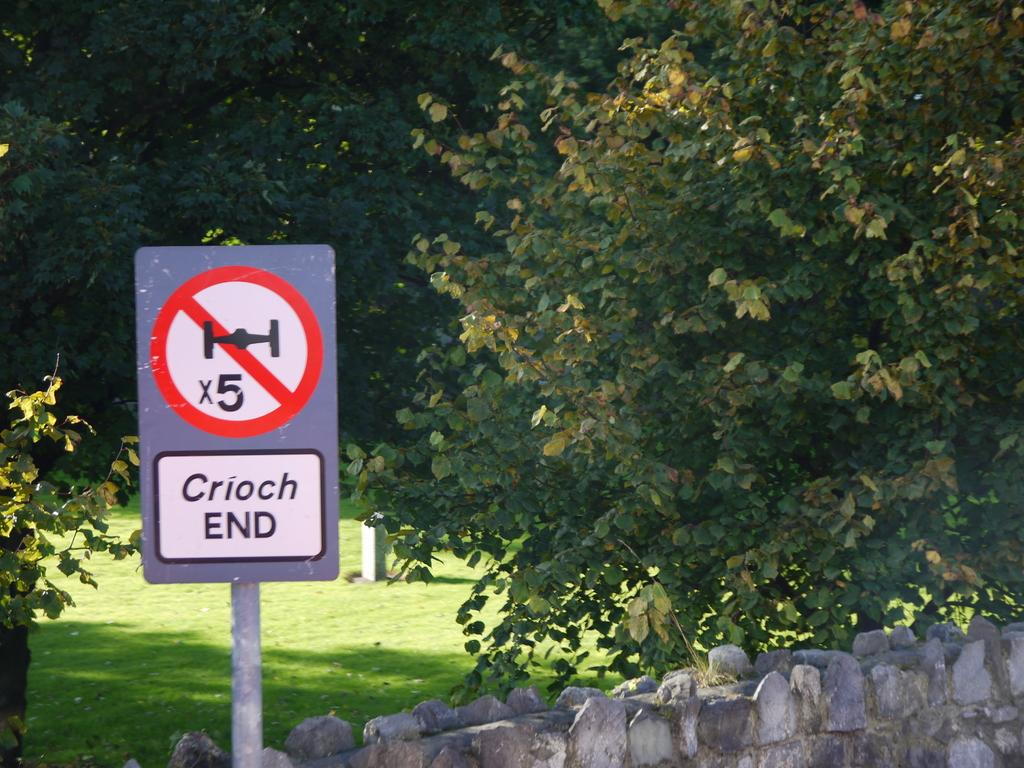<image>
Provide a brief description of the given image. A street sign with an advisory and the text Crioch END 